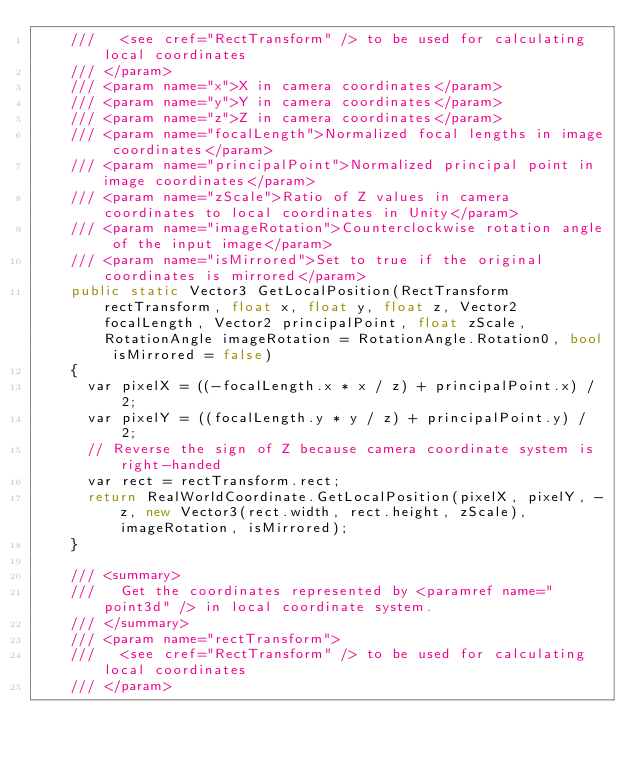<code> <loc_0><loc_0><loc_500><loc_500><_C#_>    ///   <see cref="RectTransform" /> to be used for calculating local coordinates
    /// </param>
    /// <param name="x">X in camera coordinates</param>
    /// <param name="y">Y in camera coordinates</param>
    /// <param name="z">Z in camera coordinates</param>
    /// <param name="focalLength">Normalized focal lengths in image coordinates</param>
    /// <param name="principalPoint">Normalized principal point in image coordinates</param>
    /// <param name="zScale">Ratio of Z values in camera coordinates to local coordinates in Unity</param>
    /// <param name="imageRotation">Counterclockwise rotation angle of the input image</param>
    /// <param name="isMirrored">Set to true if the original coordinates is mirrored</param>
    public static Vector3 GetLocalPosition(RectTransform rectTransform, float x, float y, float z, Vector2 focalLength, Vector2 principalPoint, float zScale, RotationAngle imageRotation = RotationAngle.Rotation0, bool isMirrored = false)
    {
      var pixelX = ((-focalLength.x * x / z) + principalPoint.x) / 2;
      var pixelY = ((focalLength.y * y / z) + principalPoint.y) / 2;
      // Reverse the sign of Z because camera coordinate system is right-handed
      var rect = rectTransform.rect;
      return RealWorldCoordinate.GetLocalPosition(pixelX, pixelY, -z, new Vector3(rect.width, rect.height, zScale), imageRotation, isMirrored);
    }

    /// <summary>
    ///   Get the coordinates represented by <paramref name="point3d" /> in local coordinate system.
    /// </summary>
    /// <param name="rectTransform">
    ///   <see cref="RectTransform" /> to be used for calculating local coordinates
    /// </param></code> 